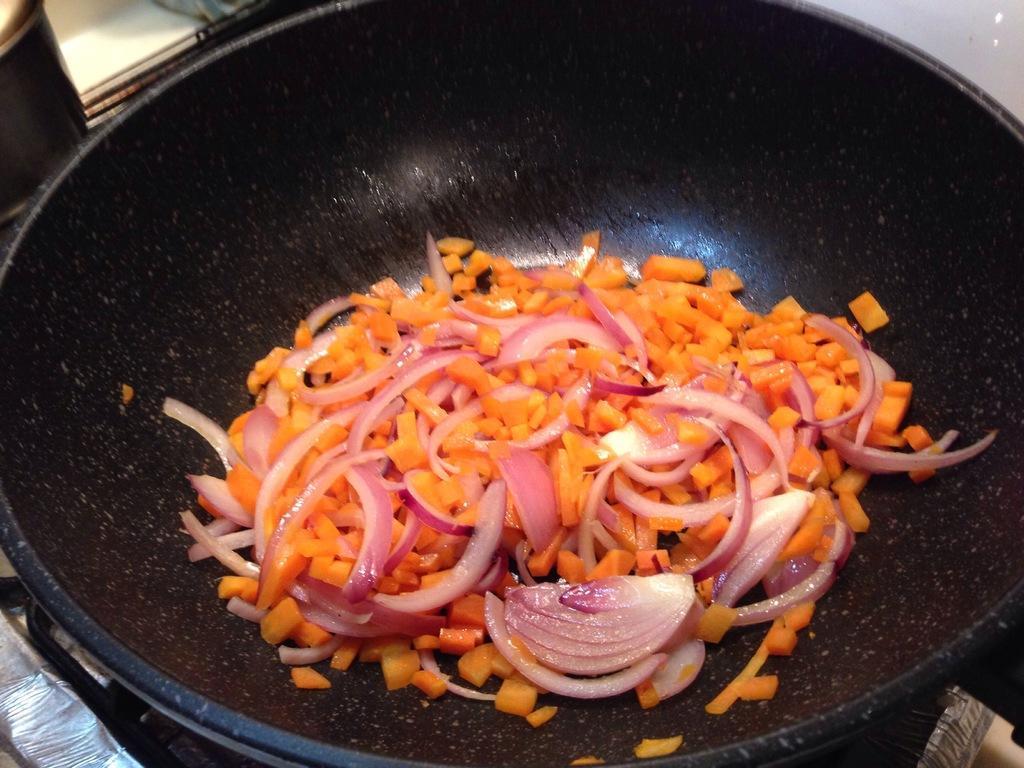Please provide a concise description of this image. This picture shows a pin on the stove. We see chopped carrot and onion pieces in it. 